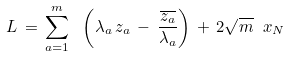<formula> <loc_0><loc_0><loc_500><loc_500>L \, = \, \sum _ { a = 1 } ^ { m } \ \left ( \lambda _ { a } \, z _ { a } \, - \, \frac { \overline { { { z _ { a } } } } } { \lambda _ { a } } \right ) \, + \, 2 \sqrt { m } \ x _ { N }</formula> 